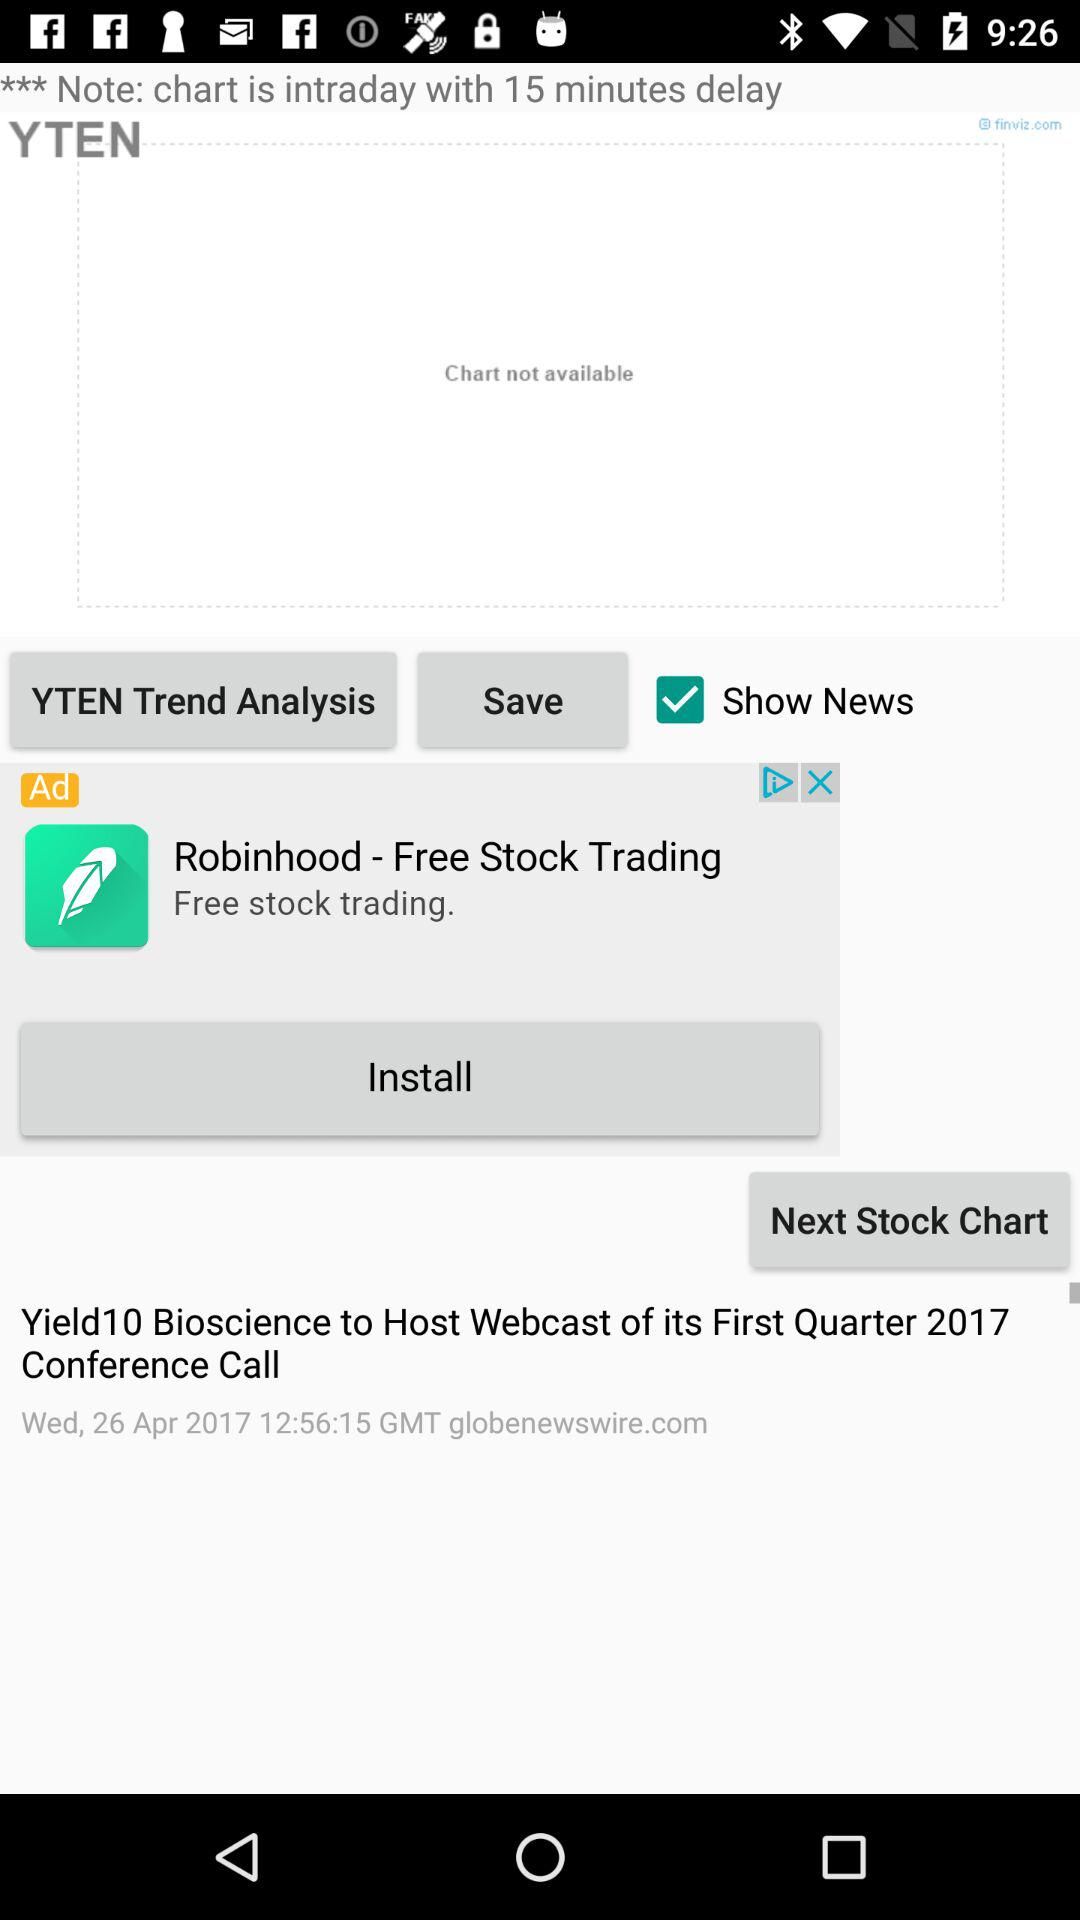By how many minutes is the chart delayed? The chart is delayed by 15 minutes. 